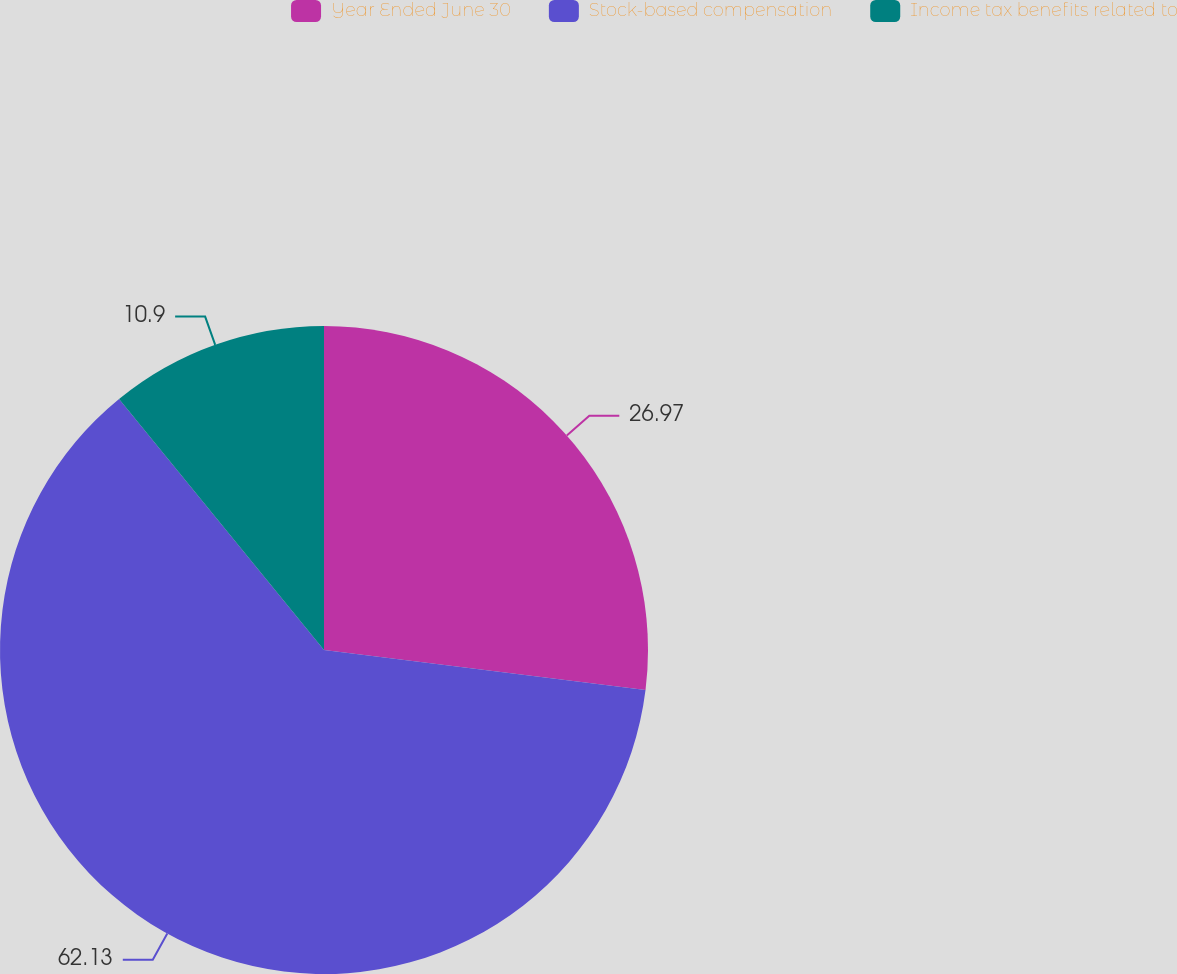<chart> <loc_0><loc_0><loc_500><loc_500><pie_chart><fcel>Year Ended June 30<fcel>Stock-based compensation<fcel>Income tax benefits related to<nl><fcel>26.97%<fcel>62.13%<fcel>10.9%<nl></chart> 